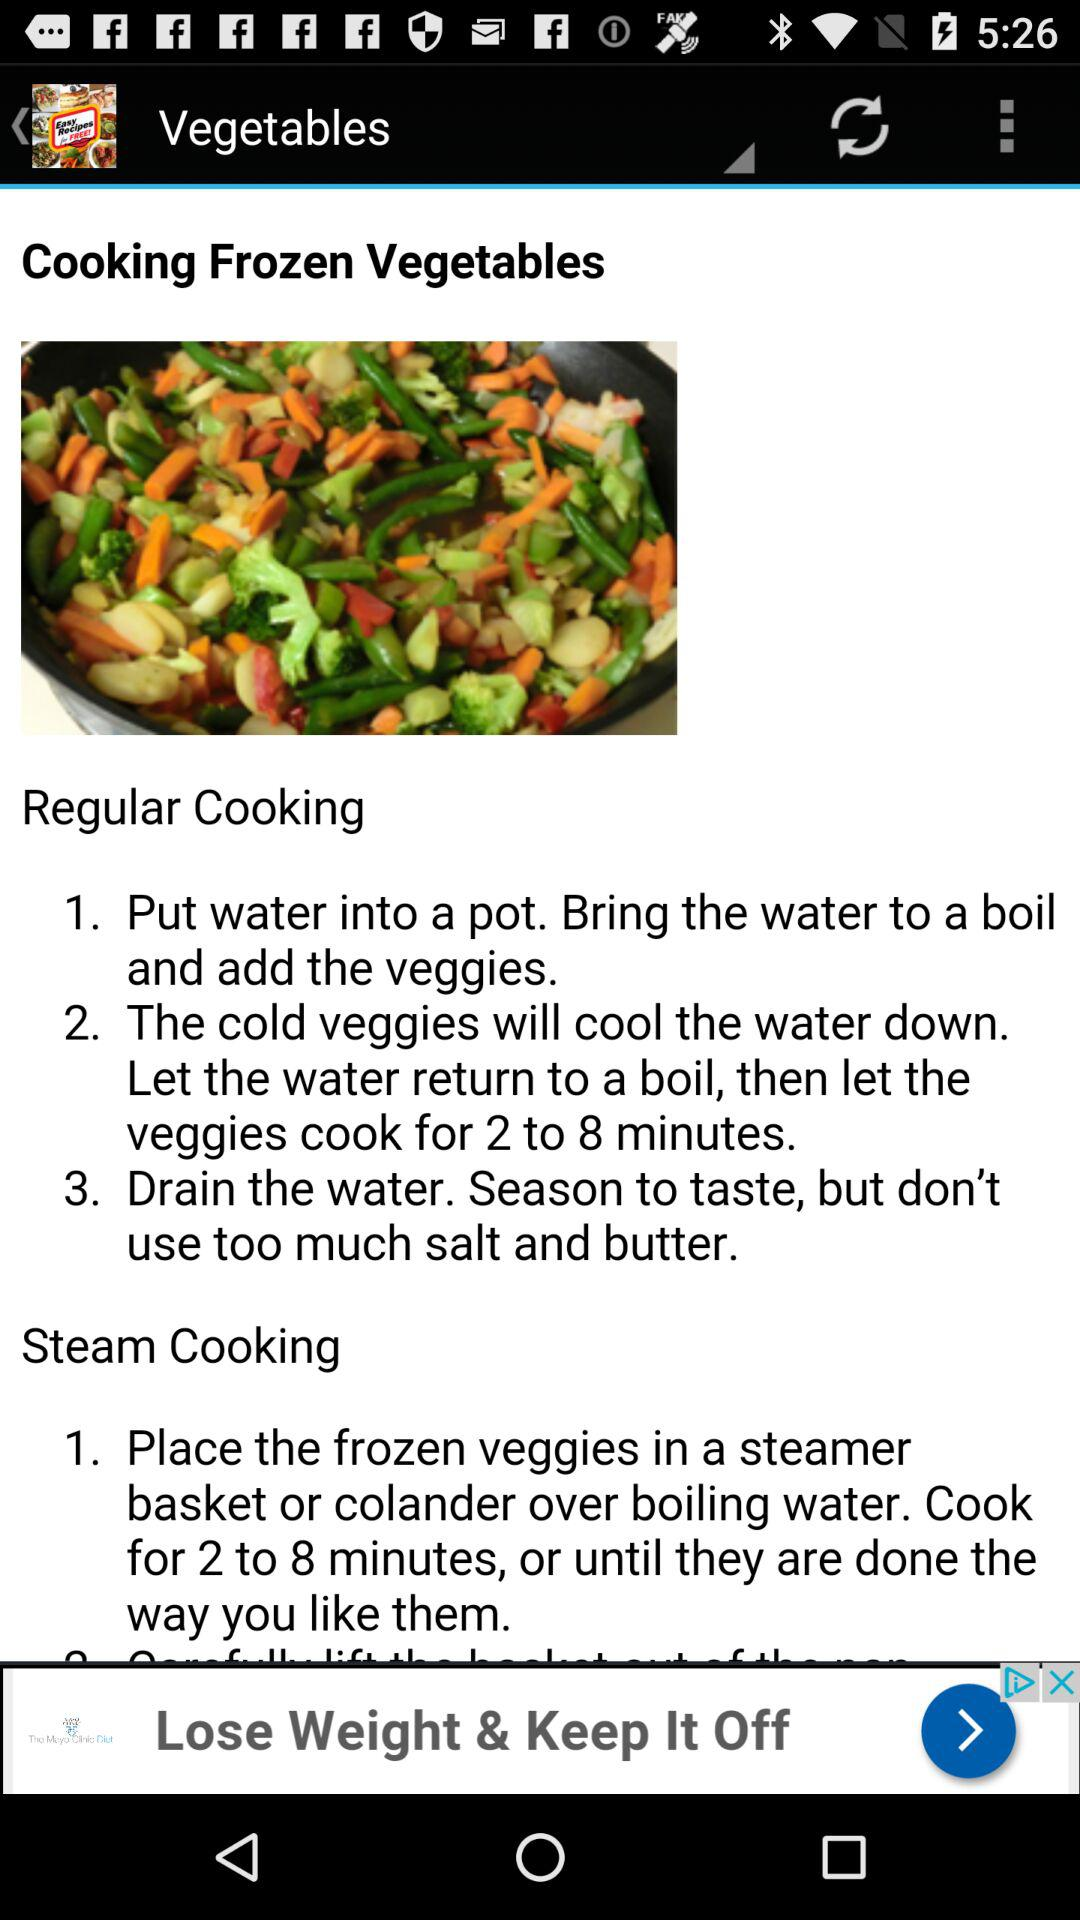How many steps are there in the regular cooking method?
Answer the question using a single word or phrase. 3 